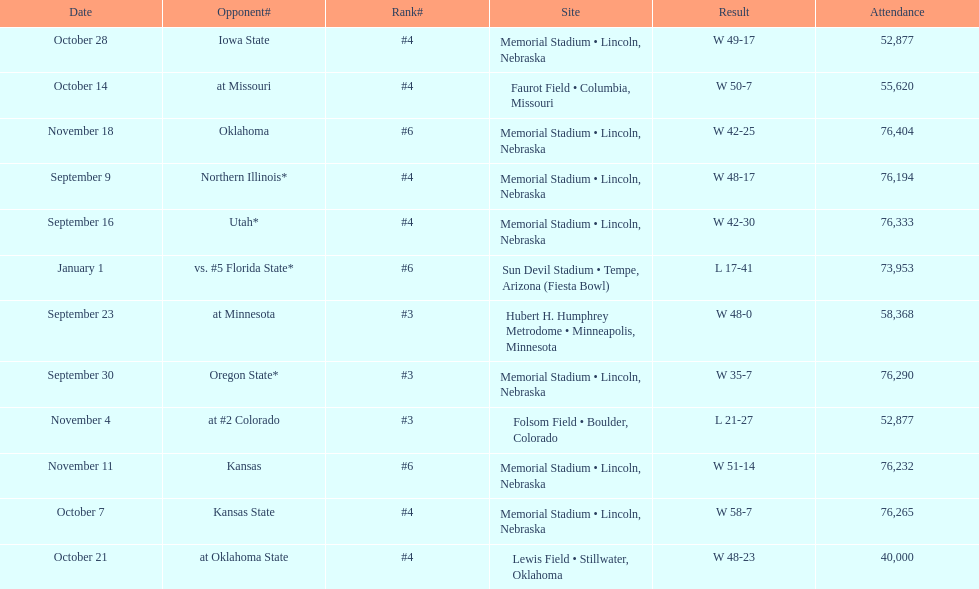How many games did they win by more than 7? 10. 